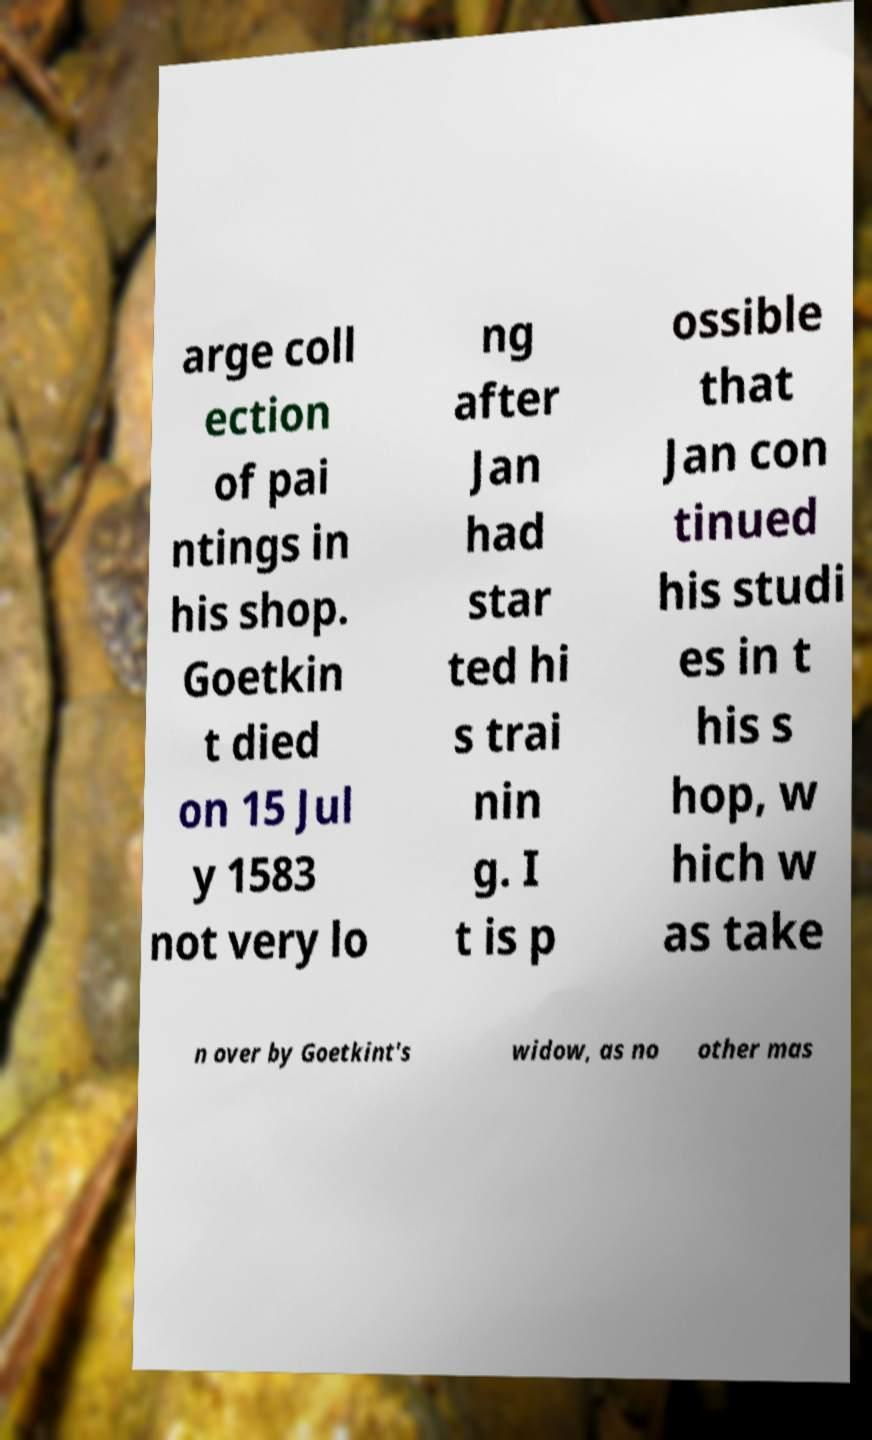Please identify and transcribe the text found in this image. arge coll ection of pai ntings in his shop. Goetkin t died on 15 Jul y 1583 not very lo ng after Jan had star ted hi s trai nin g. I t is p ossible that Jan con tinued his studi es in t his s hop, w hich w as take n over by Goetkint's widow, as no other mas 